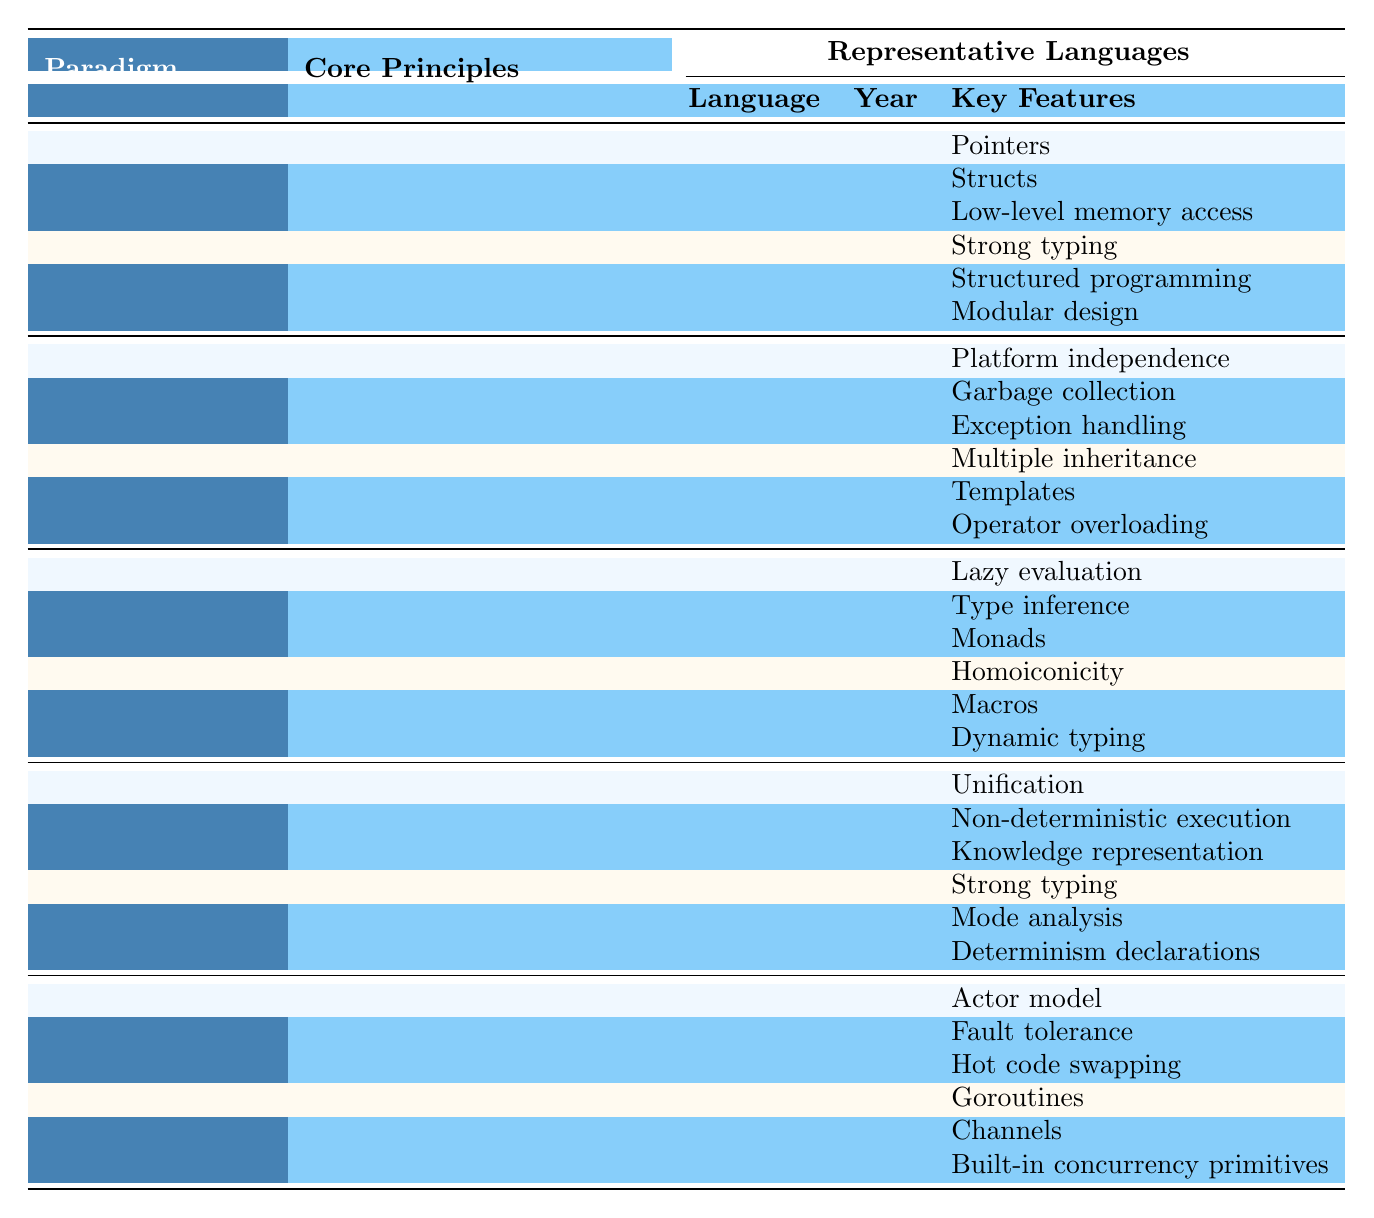What are the core principles of the Object-Oriented paradigm? The table lists the core principles for the Object-Oriented paradigm as follows: Encapsulation, Inheritance, and Polymorphism.
Answer: Encapsulation, Inheritance, Polymorphism Which programming language was introduced first, C or Java? By checking the year of introduction, C was introduced in 1972, whereas Java was introduced in 1995. Since 1972 is earlier than 1995, C was introduced first.
Answer: C How many key features does Haskell have listed in the table? Haskell has three key features listed: Lazy evaluation, Type inference, and Monads.
Answer: 3 Is it true that all languages in the Functional paradigm allow for recursion? The table shows that recursion is a core principle of the Functional paradigm, hence all representative languages under this paradigm, such as Haskell and Lisp, support recursion.
Answer: Yes Which paradigm has the least number of listed representative languages? The Logic paradigm has only two representative languages (Prolog and Mercury), while others have more. Therefore, it has the least number of listed languages.
Answer: Logic What are the key features of the language Go? According to the table, Go has three key features: Goroutines, Channels, and Built-in concurrency primitives.
Answer: Goroutines, Channels, Built-in concurrency primitives In what year was Lisp created compared to C++? Lisp was created in 1958 and C++ in 1979. Thus, Lisp was created earlier.
Answer: Lisp was created earlier Which programming paradigm emphasizes immutability? The Functional paradigm emphasizes immutability as one of its core principles.
Answer: Functional Count the total number of languages represented in the table across all paradigms. There are 5 paradigms with 10 languages in total: 2 for each of the 5 paradigms (Imperative, Object-Oriented, Functional, Logic, and Concurrent). So, 5 * 2 = 10 languages in total.
Answer: 10 What is a common feature shared by both languages in the Concurrent paradigm? Both languages, Erlang and Go, share the common feature of communication as part of their core principles.
Answer: Communication 